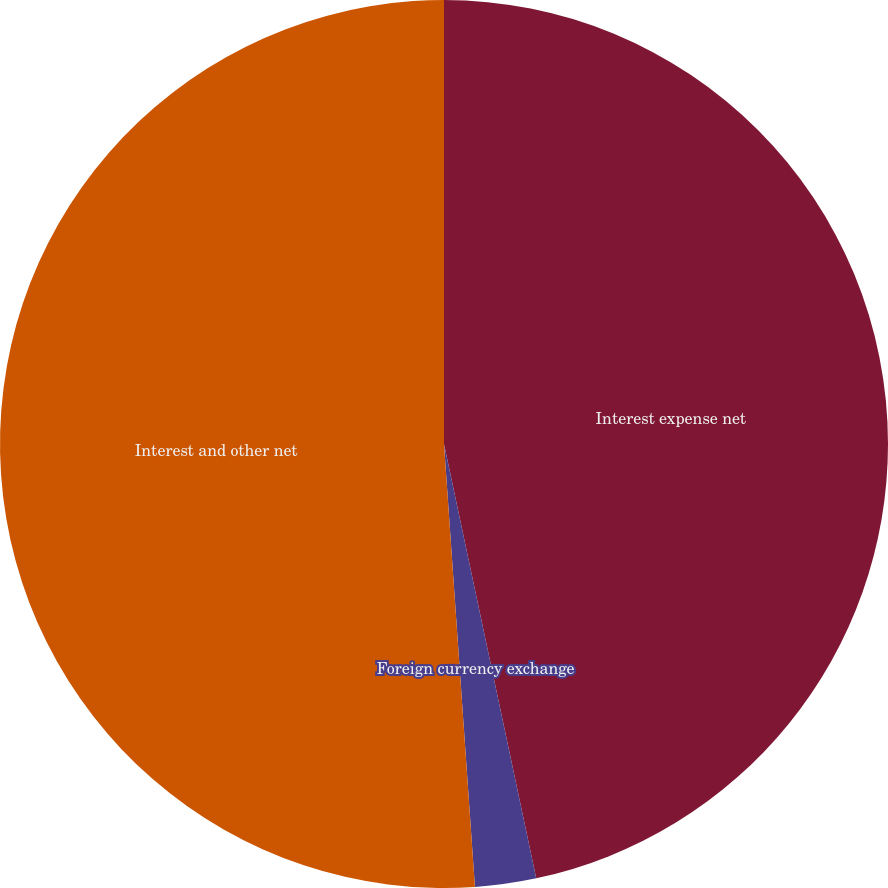<chart> <loc_0><loc_0><loc_500><loc_500><pie_chart><fcel>Interest expense net<fcel>Foreign currency exchange<fcel>Interest and other net<nl><fcel>46.67%<fcel>2.22%<fcel>51.11%<nl></chart> 